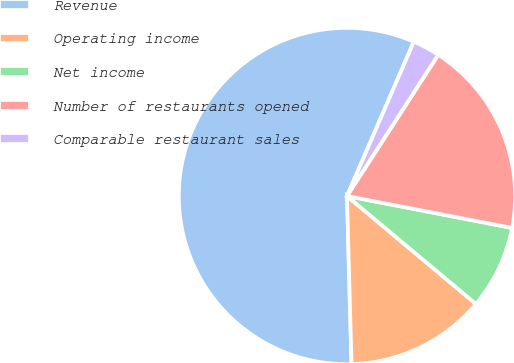Convert chart to OTSL. <chart><loc_0><loc_0><loc_500><loc_500><pie_chart><fcel>Revenue<fcel>Operating income<fcel>Net income<fcel>Number of restaurants opened<fcel>Comparable restaurant sales<nl><fcel>56.94%<fcel>13.48%<fcel>8.05%<fcel>18.91%<fcel>2.62%<nl></chart> 